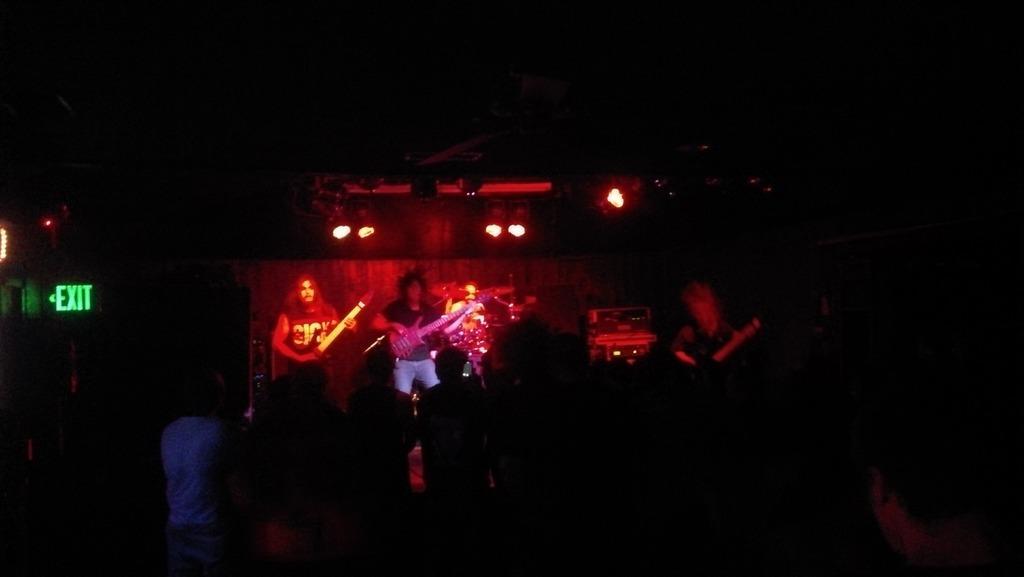Describe this image in one or two sentences. This image is dark. In this image we can see many people standing. On the left side there is an exit board. And there is a stage. On the stage there are three persons playing guitar. Also there are lights. 